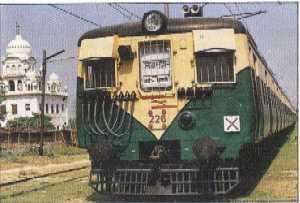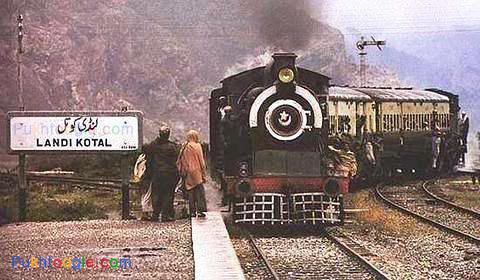The first image is the image on the left, the second image is the image on the right. Examine the images to the left and right. Is the description "The trains in both images travel on straight tracks in the same direction." accurate? Answer yes or no. No. The first image is the image on the left, the second image is the image on the right. Analyze the images presented: Is the assertion "The train in one of the images is green and yellow." valid? Answer yes or no. Yes. 